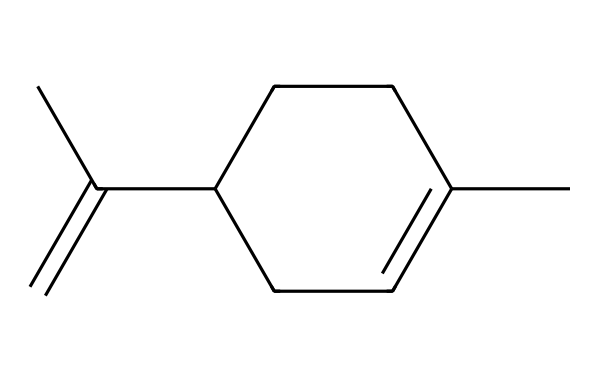What is the molecular formula of this compound? To determine the molecular formula, we need to count the number of carbon (C) and hydrogen (H) atoms present in the structure. The given SMILES notation indicates that there are 10 carbon atoms and 14 hydrogen atoms. Thus, the molecular formula is C10H14.
Answer: C10H14 How many rings are present in this chemical structure? By analyzing the SMILES representation, we can identify that 'C1' indicates the start of a ring structure. The presence of 'CC1' later indicates that a ring is closed. This compound has one cyclic structure or ring.
Answer: 1 What type of compound is represented by this structure? The presence of multiple carbon-carbon single and double bonds without any nitrogen or oxygen atoms suggests that this compound is likely a hydrocarbon. Since it is aromatic and includes a cyclic structure, it is classified as a terpene.
Answer: terpene What is the degree of unsaturation in this molecule? The degree of unsaturation can be calculated based on the number of rings and double bonds. Each ring and each double bond contributes to the degree of unsaturation. The structure has one ring and one double bond, resulting in a total degree of unsaturation of 2.
Answer: 2 Which functional group, if any, is present in this chemical structure? Analyzing the structure, there are no functional groups present such as alcohols, acids, or esters. It appears to consist solely of carbon and hydrogen, characteristic of terpenes which do not have functional groups attached. Therefore, there are no distinct functional groups.
Answer: none 